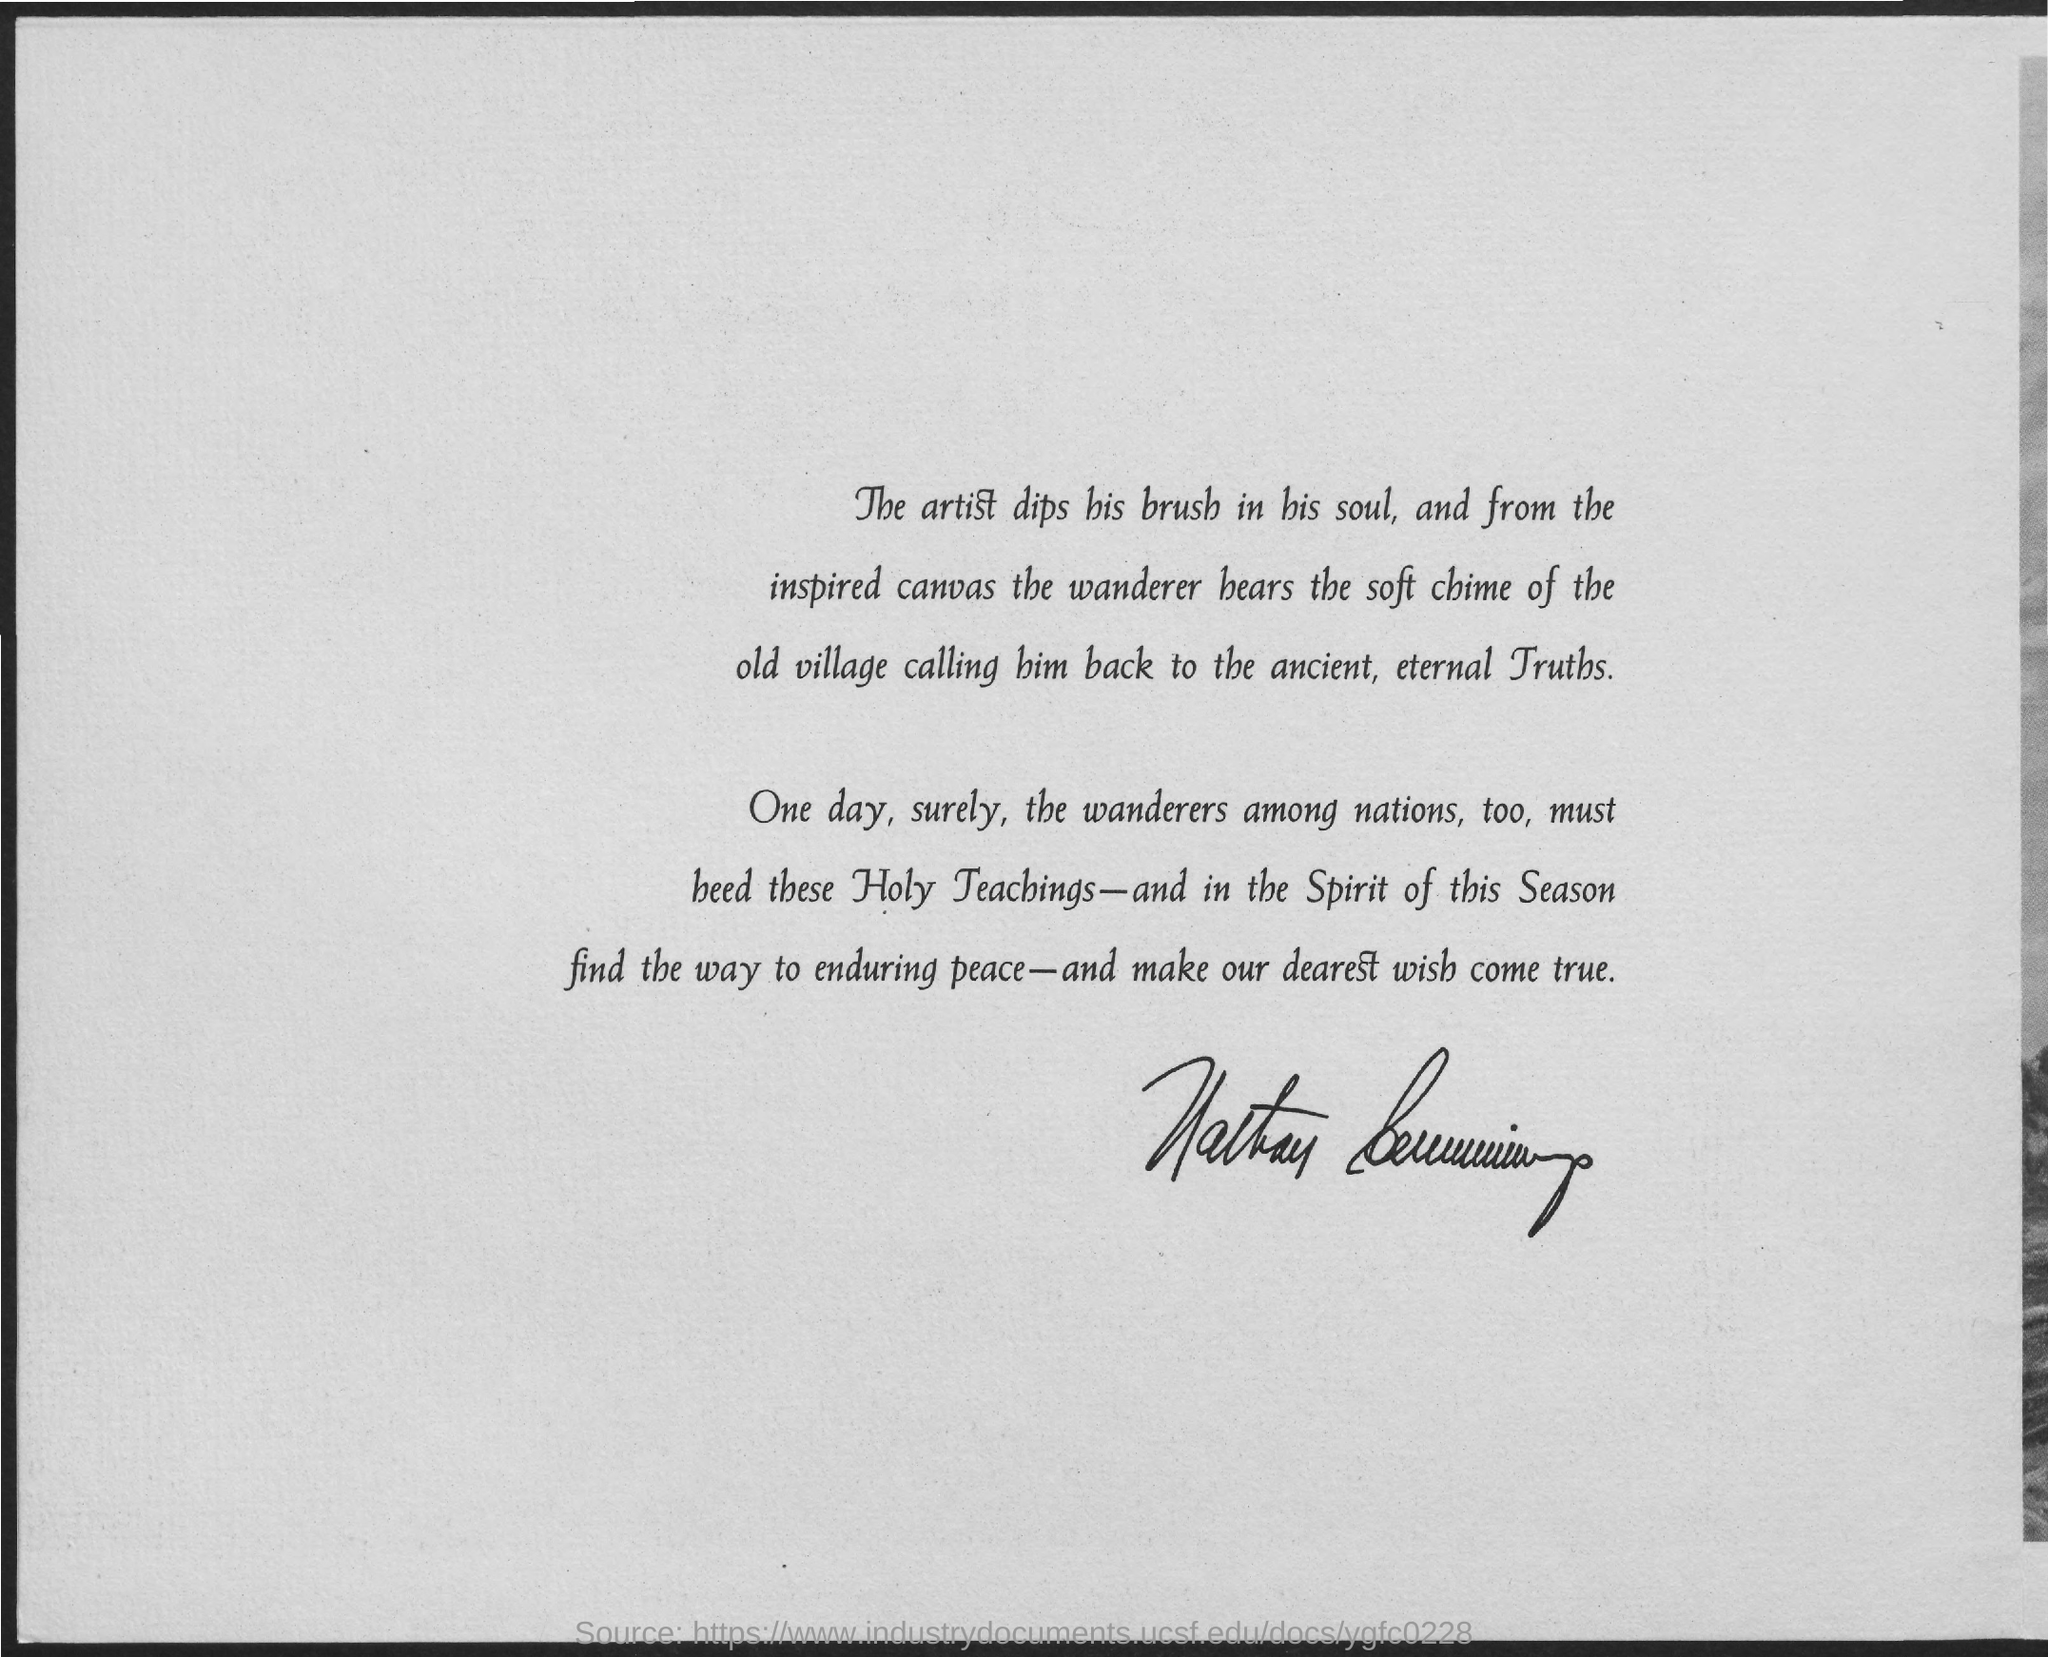Specify some key components in this picture. It is imperative that all nations, including the Wanderers, adopt and abide by these Holy Teachings. 